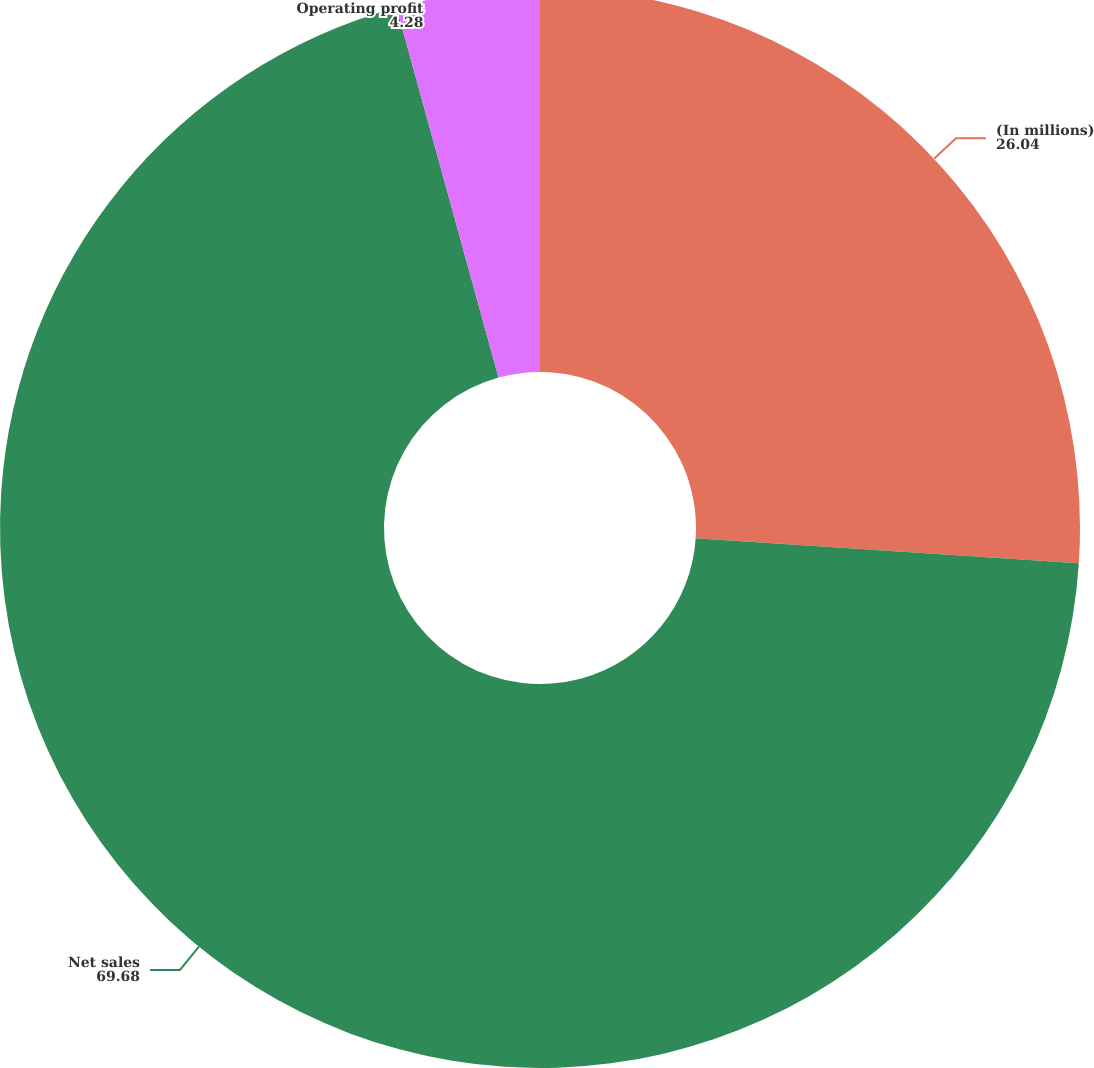<chart> <loc_0><loc_0><loc_500><loc_500><pie_chart><fcel>(In millions)<fcel>Net sales<fcel>Operating profit<nl><fcel>26.04%<fcel>69.68%<fcel>4.28%<nl></chart> 